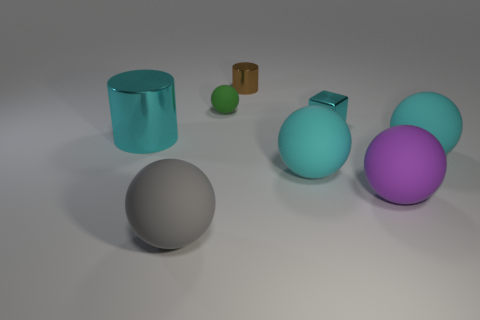Subtract all gray spheres. How many spheres are left? 4 Subtract all tiny green matte spheres. How many spheres are left? 4 Subtract 2 spheres. How many spheres are left? 3 Subtract all blue balls. Subtract all purple cylinders. How many balls are left? 5 Add 2 big cyan blocks. How many objects exist? 10 Subtract all cylinders. How many objects are left? 6 Subtract all big rubber spheres. Subtract all tiny brown cylinders. How many objects are left? 3 Add 5 large purple matte objects. How many large purple matte objects are left? 6 Add 2 purple matte things. How many purple matte things exist? 3 Subtract 0 blue blocks. How many objects are left? 8 